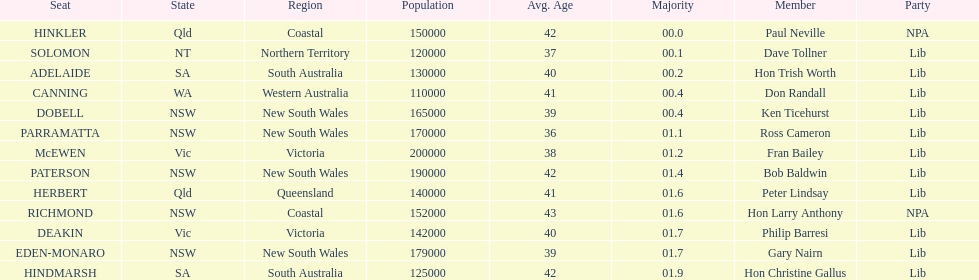What's the overall count of members? 13. 